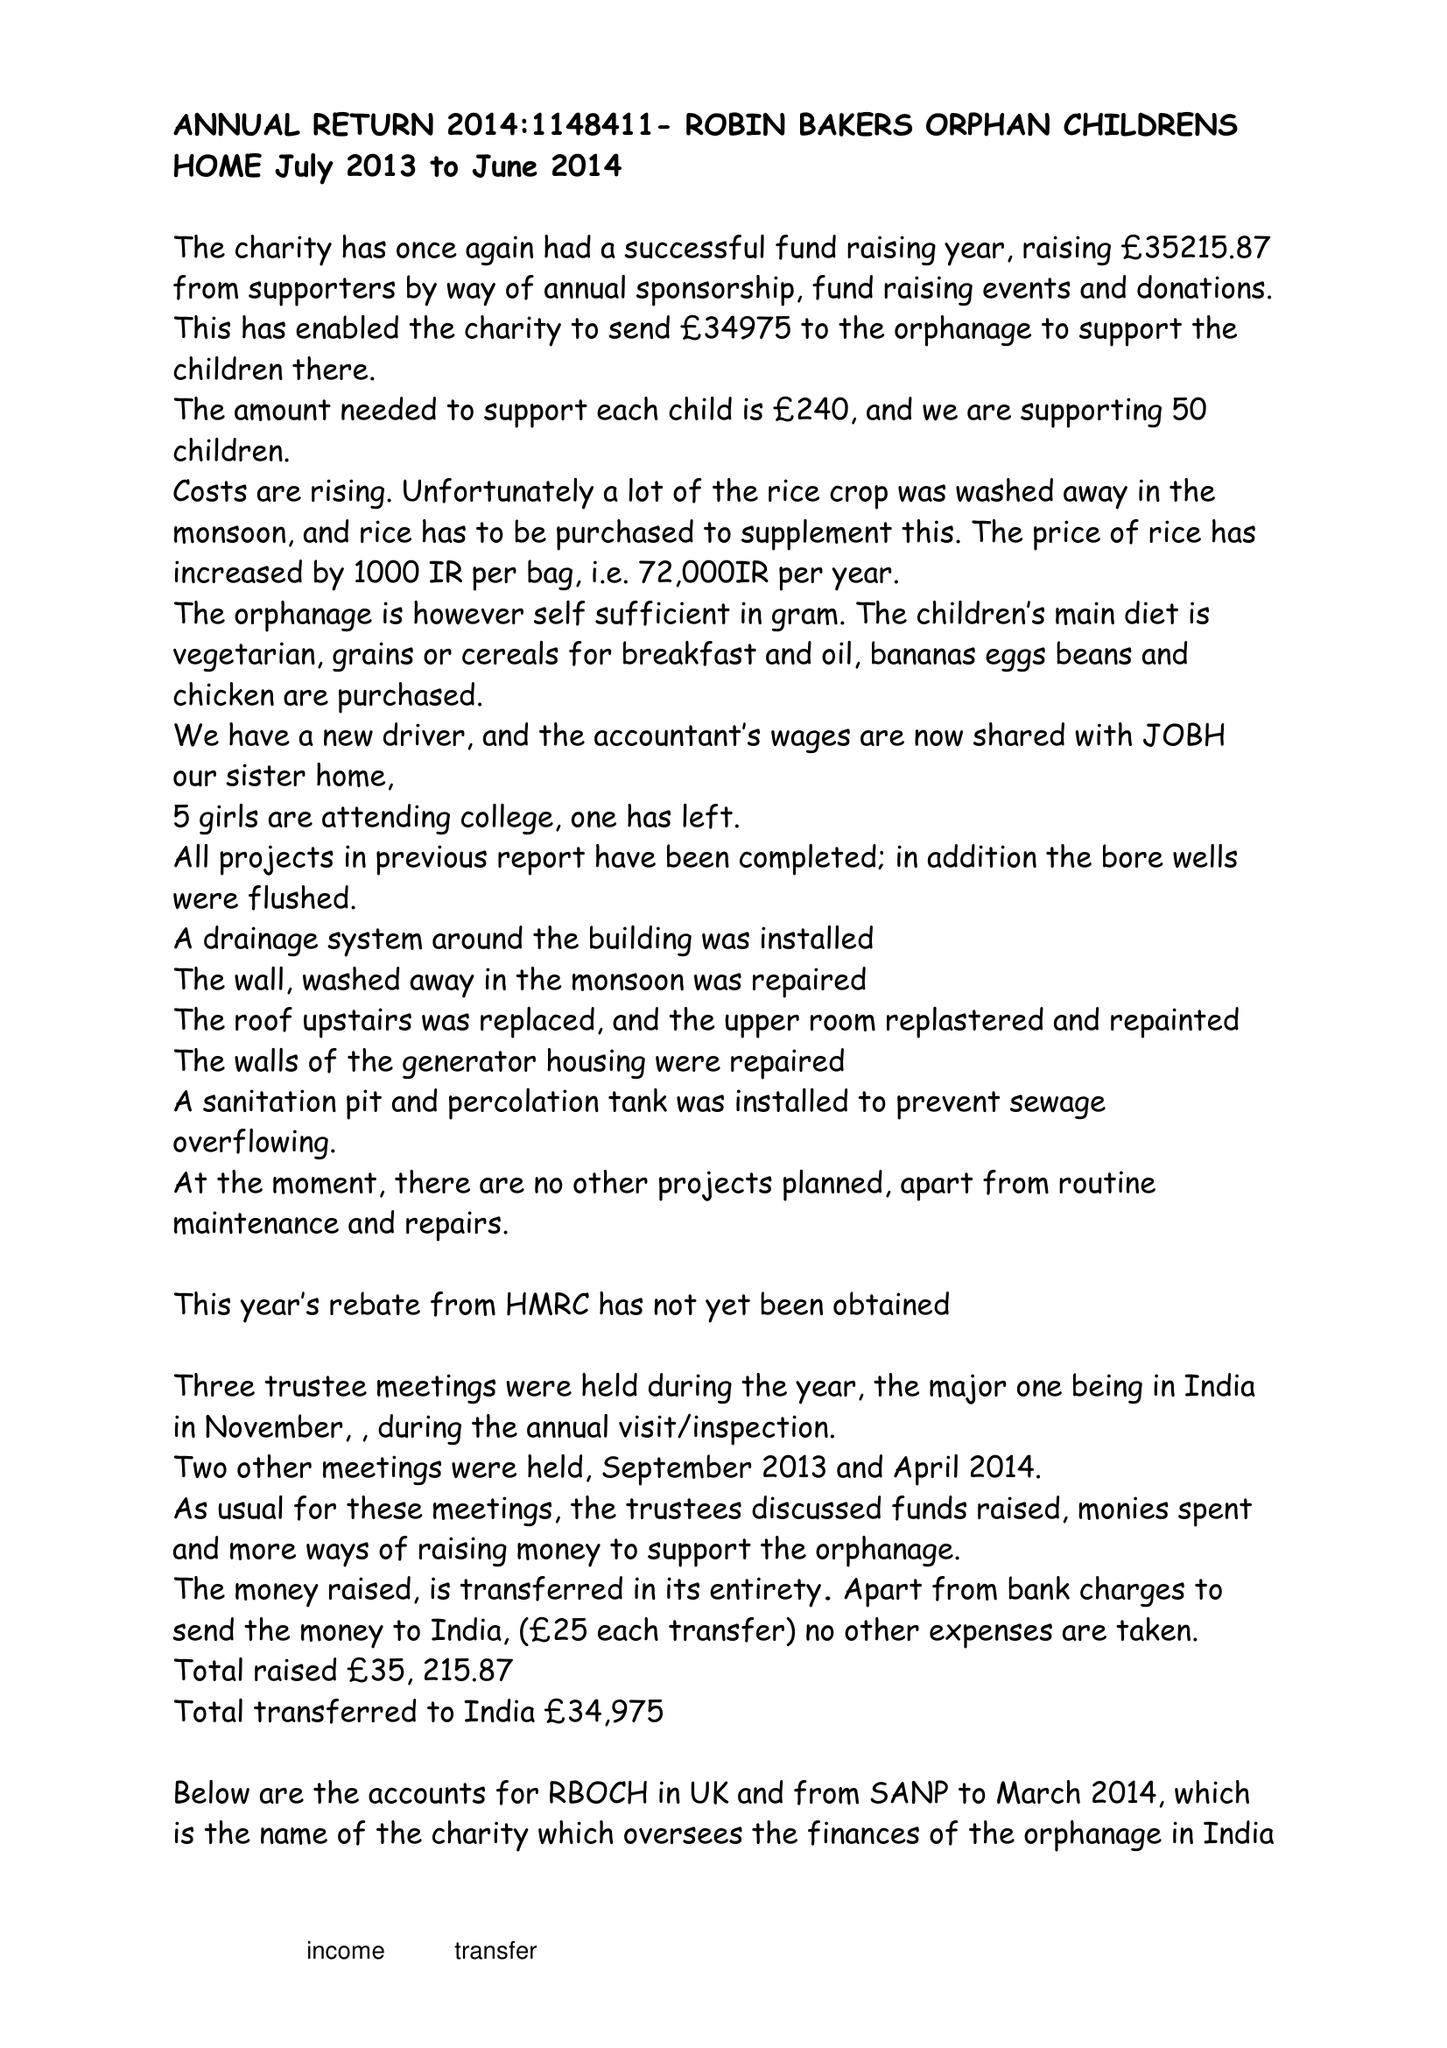What is the value for the spending_annually_in_british_pounds?
Answer the question using a single word or phrase. 34975.00 